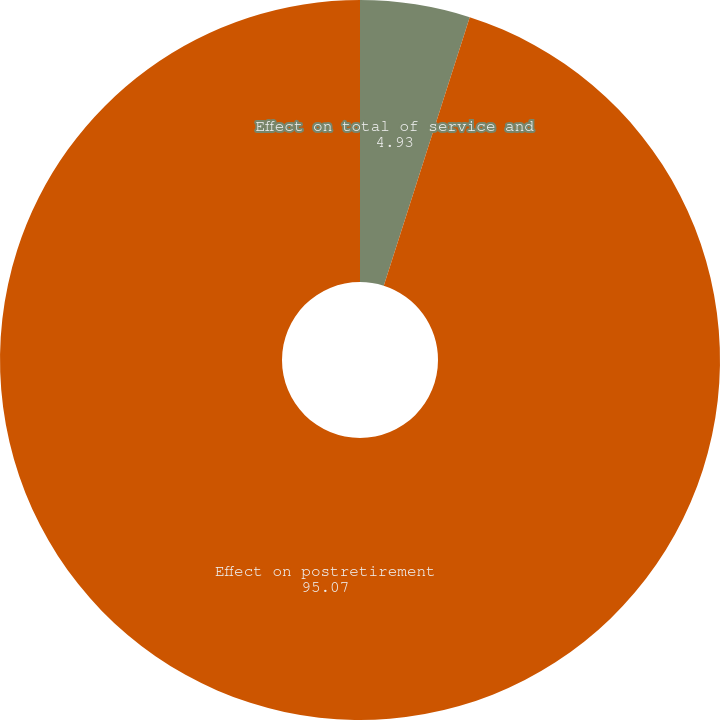<chart> <loc_0><loc_0><loc_500><loc_500><pie_chart><fcel>Effect on total of service and<fcel>Effect on postretirement<nl><fcel>4.93%<fcel>95.07%<nl></chart> 